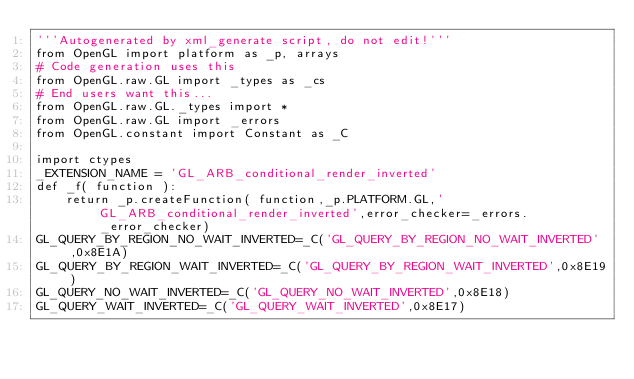Convert code to text. <code><loc_0><loc_0><loc_500><loc_500><_Python_>'''Autogenerated by xml_generate script, do not edit!'''
from OpenGL import platform as _p, arrays
# Code generation uses this
from OpenGL.raw.GL import _types as _cs
# End users want this...
from OpenGL.raw.GL._types import *
from OpenGL.raw.GL import _errors
from OpenGL.constant import Constant as _C

import ctypes
_EXTENSION_NAME = 'GL_ARB_conditional_render_inverted'
def _f( function ):
    return _p.createFunction( function,_p.PLATFORM.GL,'GL_ARB_conditional_render_inverted',error_checker=_errors._error_checker)
GL_QUERY_BY_REGION_NO_WAIT_INVERTED=_C('GL_QUERY_BY_REGION_NO_WAIT_INVERTED',0x8E1A)
GL_QUERY_BY_REGION_WAIT_INVERTED=_C('GL_QUERY_BY_REGION_WAIT_INVERTED',0x8E19)
GL_QUERY_NO_WAIT_INVERTED=_C('GL_QUERY_NO_WAIT_INVERTED',0x8E18)
GL_QUERY_WAIT_INVERTED=_C('GL_QUERY_WAIT_INVERTED',0x8E17)

</code> 